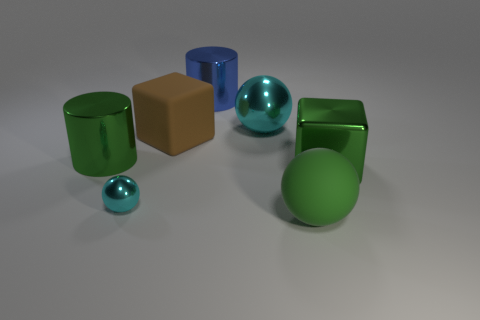There is a green metallic object on the left side of the big blue cylinder; what shape is it?
Give a very brief answer. Cylinder. Are there any yellow metal blocks of the same size as the green rubber ball?
Give a very brief answer. No. There is a blue cylinder that is the same size as the brown rubber object; what material is it?
Your answer should be compact. Metal. What is the size of the cyan shiny object that is to the left of the blue object?
Your response must be concise. Small. There is a green metallic cylinder; is its size the same as the cyan thing that is in front of the large brown rubber cube?
Your answer should be compact. No. What is the color of the large block in front of the large metallic cylinder that is in front of the big brown rubber cube?
Provide a short and direct response. Green. Are there an equal number of large cylinders behind the large brown rubber block and brown blocks in front of the rubber sphere?
Your answer should be very brief. No. Does the big ball in front of the large green shiny cylinder have the same material as the brown object?
Offer a very short reply. Yes. What color is the sphere that is right of the small cyan thing and on the left side of the big rubber ball?
Give a very brief answer. Cyan. There is a metallic sphere to the left of the brown cube; what number of large shiny cylinders are on the left side of it?
Provide a succinct answer. 1. 